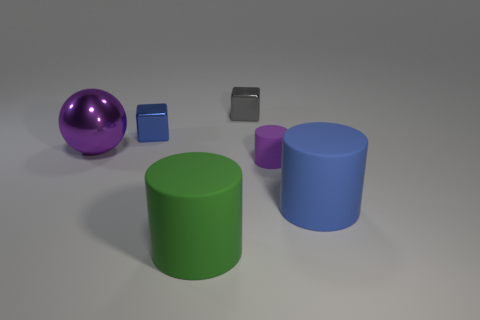What is the shape of the big thing that is to the left of the large blue rubber thing and on the right side of the tiny blue metal object?
Your answer should be compact. Cylinder. There is a blue thing that is to the right of the tiny thing that is in front of the purple metal object; what is it made of?
Provide a short and direct response. Rubber. Is the material of the big cylinder that is in front of the big blue matte thing the same as the small gray cube?
Ensure brevity in your answer.  No. What size is the metal block that is on the left side of the gray block?
Your answer should be very brief. Small. Is there a purple metal thing in front of the cylinder to the left of the tiny gray cube?
Your response must be concise. No. There is a rubber object right of the purple cylinder; is its color the same as the small thing that is in front of the large ball?
Your answer should be compact. No. What is the color of the metal sphere?
Your answer should be compact. Purple. Is there anything else that has the same color as the big metal object?
Provide a succinct answer. Yes. There is a matte cylinder that is both to the right of the gray metallic object and in front of the purple rubber cylinder; what color is it?
Your answer should be compact. Blue. Does the purple cylinder that is to the right of the gray thing have the same size as the big purple object?
Give a very brief answer. No. 